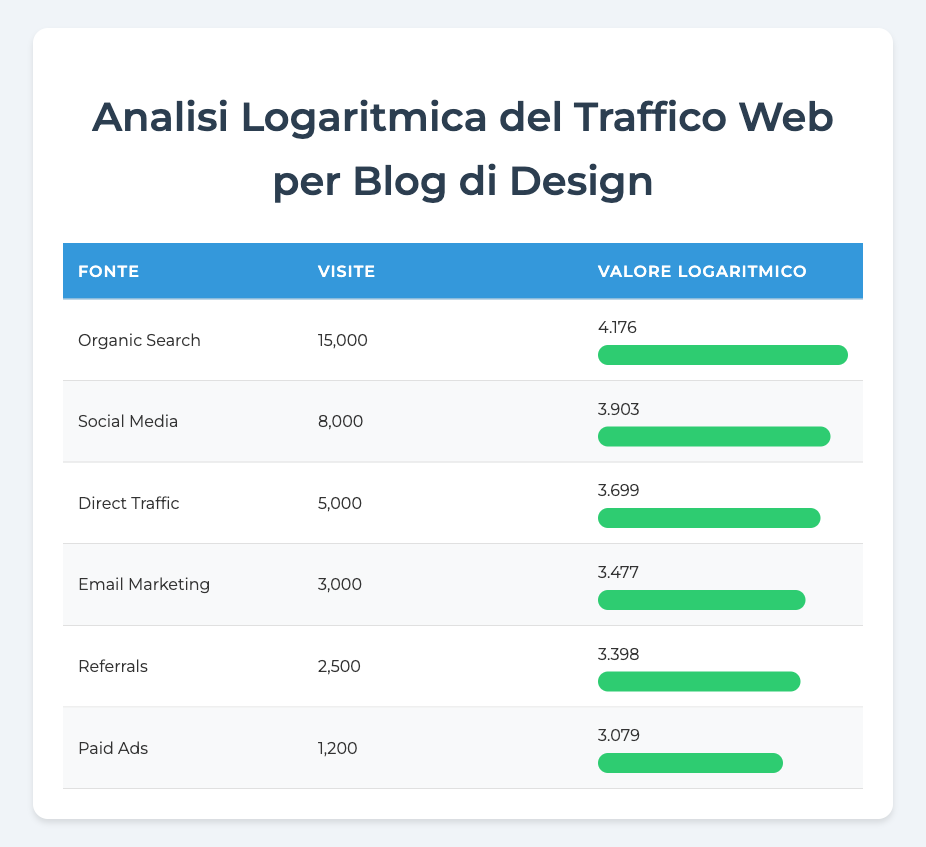What is the highest source of website traffic visits? By looking at the "Visite" column in the table, the highest value is for "Organic Search" with 15,000 visits.
Answer: Organic Search What is the logarithmic value for Social Media traffic? The "logarithmic_value" column shows that for "Social Media", the value is 3.903.
Answer: 3.903 How many more visits does Organic Search have compared to Paid Ads? Organic Search has 15,000 visits and Paid Ads has 1,200 visits. The difference is 15,000 - 1,200 = 13,800.
Answer: 13,800 Is the total visits for Email Marketing and Referrals greater than that for Direct Traffic? Email Marketing has 3,000 visits and Referrals has 2,500 visits, totaling 3,000 + 2,500 = 5,500. Direct Traffic has 5,000 visits, which is less than 5,500, so the answer is yes.
Answer: Yes What is the average number of visits across all traffic sources? First, sum all visits: 15,000 + 8,000 + 5,000 + 3,000 + 2,500 + 1,200 = 34,700. Then divide by the number of sources, which is 6: 34,700 / 6 = 5,783.33.
Answer: 5,783.33 Is Social Media the second highest source of visits? The visits for Social Media are 8,000, which is the second highest value in the visits column, ranking below Organic Search with 15,000 visits.
Answer: Yes Calculate the percentage of total visits that come from Direct Traffic. Direct Traffic has 5,000 visits. The total visits from all sources is 34,700. Hence, (5,000 / 34,700) * 100 = 14.43%.
Answer: 14.43% How do the visits from Paid Ads compare to those from Email Marketing? Paid Ads has 1,200 visits while Email Marketing has 3,000. To find how they compare, we see that 1,200 is less than 3,000. Therefore, Paid Ads has fewer visits than Email Marketing.
Answer: Fewer What percentage of visits do Organic Search represent among total visits? Organic Search has 15,000 visits. The total visits across all sources is 34,700. To calculate the percentage: (15,000 / 34,700) * 100 = 43.27%.
Answer: 43.27% 